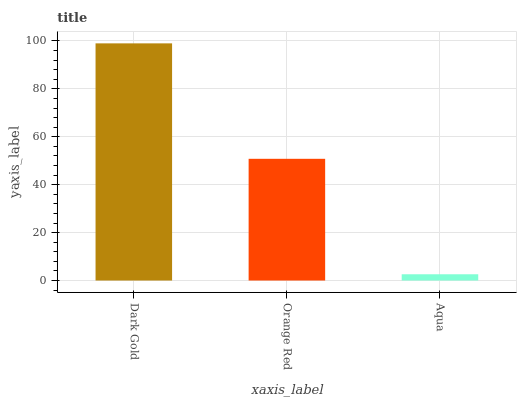Is Aqua the minimum?
Answer yes or no. Yes. Is Dark Gold the maximum?
Answer yes or no. Yes. Is Orange Red the minimum?
Answer yes or no. No. Is Orange Red the maximum?
Answer yes or no. No. Is Dark Gold greater than Orange Red?
Answer yes or no. Yes. Is Orange Red less than Dark Gold?
Answer yes or no. Yes. Is Orange Red greater than Dark Gold?
Answer yes or no. No. Is Dark Gold less than Orange Red?
Answer yes or no. No. Is Orange Red the high median?
Answer yes or no. Yes. Is Orange Red the low median?
Answer yes or no. Yes. Is Aqua the high median?
Answer yes or no. No. Is Aqua the low median?
Answer yes or no. No. 